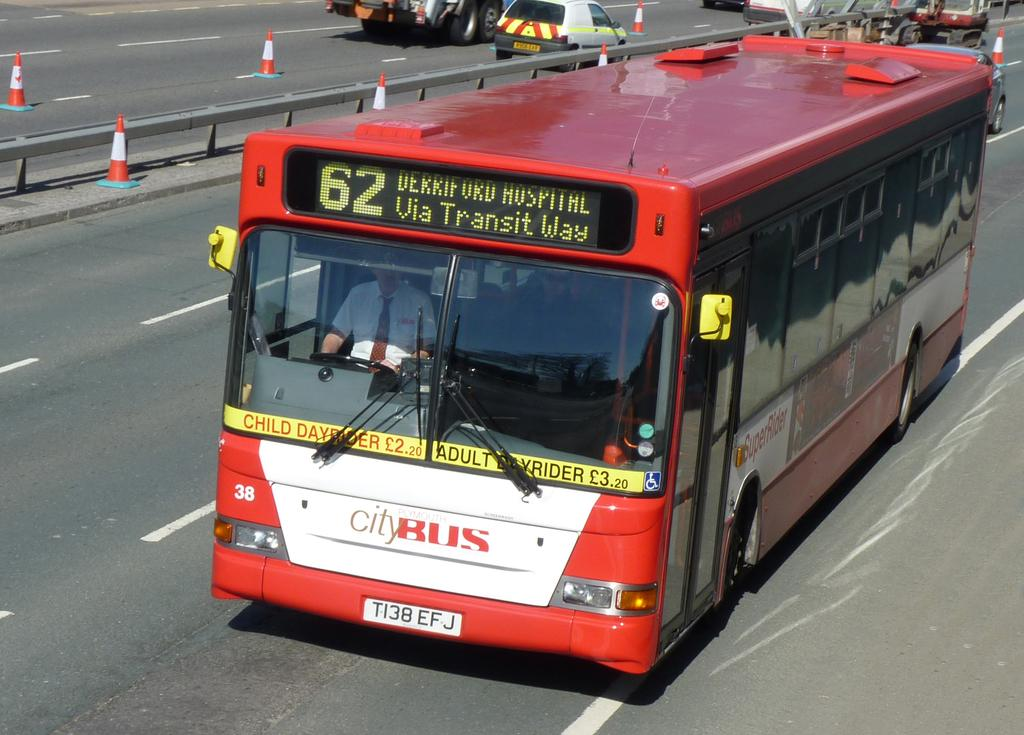What is happening on the road in the image? There are vehicles on the road in the image. What can be seen behind the vehicles? There is a fencing behind the vehicles. What objects are present to guide or separate traffic in the image? Road divider cones are present in the image. Where can one find a shaded seat in the image? There is no shaded seat present in the image. 